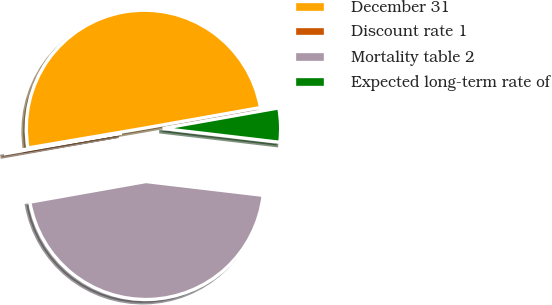Convert chart. <chart><loc_0><loc_0><loc_500><loc_500><pie_chart><fcel>December 31<fcel>Discount rate 1<fcel>Mortality table 2<fcel>Expected long-term rate of<nl><fcel>49.89%<fcel>0.11%<fcel>45.34%<fcel>4.66%<nl></chart> 